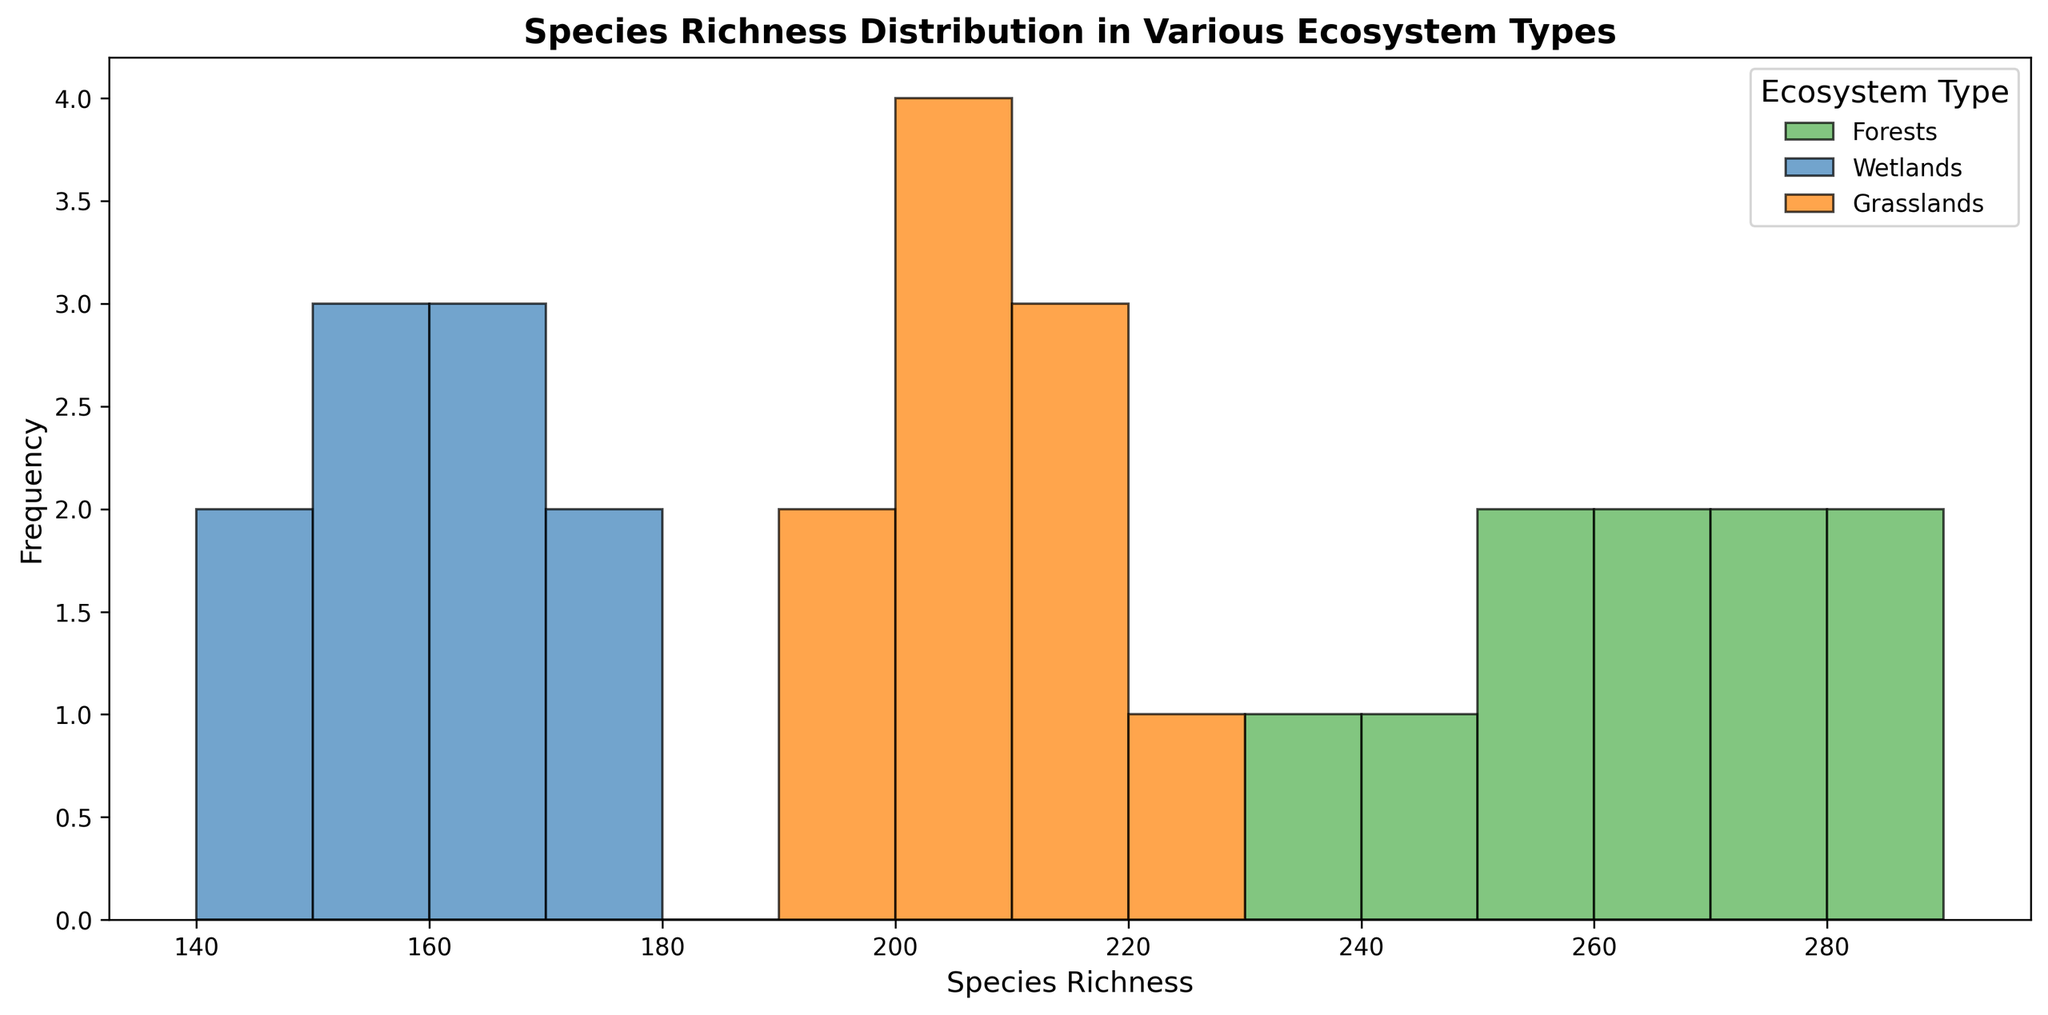Which ecosystem type shows the highest species richness overall? Look at the species richness values across all ecosystem types in the figure. The highest value observed is in the Forests category with a species richness of 285.
Answer: Forests In which ecosystem type are species richness values most clustered? Observe the spread of species richness values (width of the histogram) for each ecosystem type. Wetlands show the most clustered values around 150-170.
Answer: Wetlands Which ecosystem type has the most uniform distribution of species richness values? Analyze the spread and frequency of bars for each ecosystem type. Grasslands have a more uniform distribution with species richness values almost evenly distributed around 190-220.
Answer: Grasslands Between Forests and Grasslands, which ecosystem type has a higher median species richness? Identify the middle value of species richness for each ecosystem. For Forests, it's about 260-265, and for Grasslands, it's about 205. Comparing both, Forests have a higher median.
Answer: Forests What is the range of species richness for Wetlands? Range is the difference between the maximum and minimum values. For Wetlands, it's 175 (max) - 140 (min) = 35.
Answer: 35 Which ecosystem type has the smallest minimum species richness? Find the smallest species richness value in each ecosystem. Wetlands have the smallest minimum at 140.
Answer: Wetlands How does the frequency of species richness values between 240 and 270 compare between Forests and Grasslands? Compare the number of bars and their heights between 240 and 270 for both types. Forests have multiple high bars in this range, while Grasslands have none.
Answer: Forests have more How many different species richness intervals are present in the histogram for each ecosystem type? Count the distinct intervals on the x-axis for each ecosystem. Forests: 6, Wetlands: 6, Grasslands: 7.
Answer: Forests: 6, Wetlands: 6, Grasslands: 7 Comparing Wetlands and Grasslands, which has a higher average species richness? Compute the average for each. Wetlands are centered around 155-160, and Grasslands are centered around 205. Clearly, Grasslands have the higher average.
Answer: Grasslands 